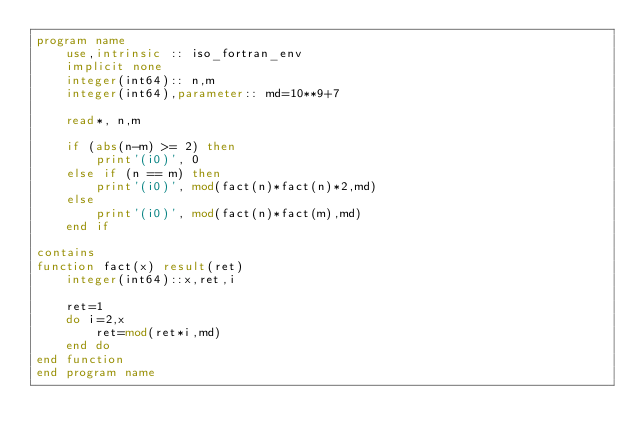Convert code to text. <code><loc_0><loc_0><loc_500><loc_500><_FORTRAN_>program name
    use,intrinsic :: iso_fortran_env
    implicit none
    integer(int64):: n,m
    integer(int64),parameter:: md=10**9+7

    read*, n,m

    if (abs(n-m) >= 2) then
        print'(i0)', 0
    else if (n == m) then
        print'(i0)', mod(fact(n)*fact(n)*2,md)
    else
        print'(i0)', mod(fact(n)*fact(m),md)
    end if

contains
function fact(x) result(ret)
    integer(int64)::x,ret,i

    ret=1
    do i=2,x
        ret=mod(ret*i,md)
    end do
end function
end program name</code> 